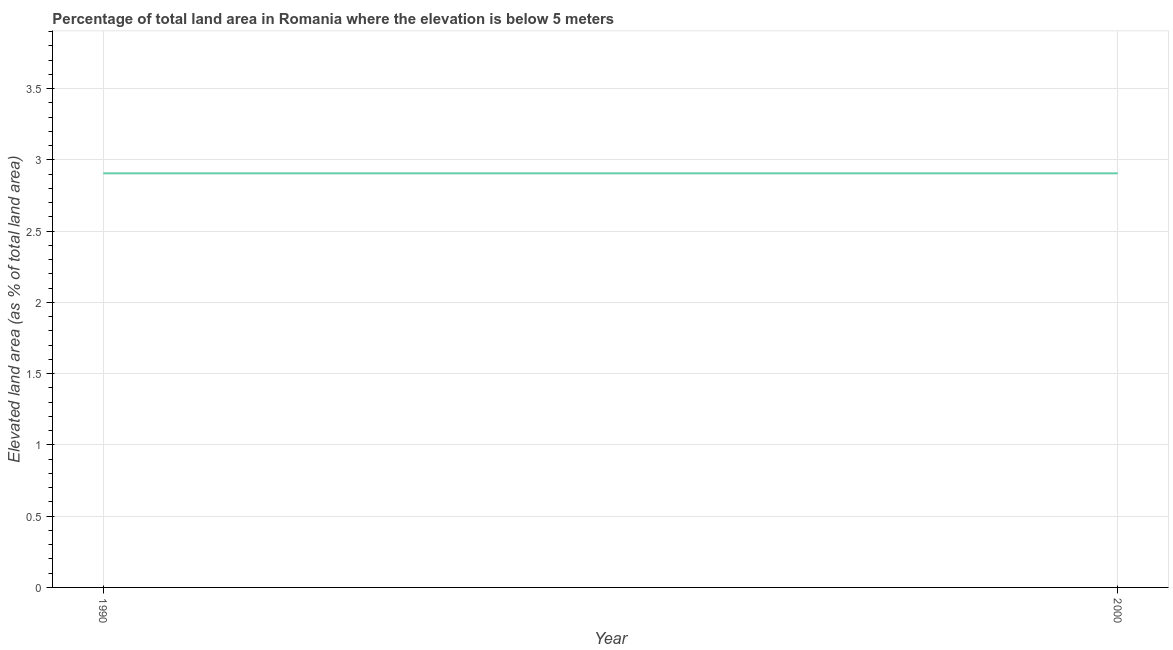What is the total elevated land area in 1990?
Give a very brief answer. 2.91. Across all years, what is the maximum total elevated land area?
Your answer should be very brief. 2.91. Across all years, what is the minimum total elevated land area?
Make the answer very short. 2.91. What is the sum of the total elevated land area?
Offer a very short reply. 5.81. What is the difference between the total elevated land area in 1990 and 2000?
Give a very brief answer. 0. What is the average total elevated land area per year?
Give a very brief answer. 2.91. What is the median total elevated land area?
Offer a very short reply. 2.91. Do a majority of the years between 1990 and 2000 (inclusive) have total elevated land area greater than 1.3 %?
Make the answer very short. Yes. Is the total elevated land area in 1990 less than that in 2000?
Give a very brief answer. No. In how many years, is the total elevated land area greater than the average total elevated land area taken over all years?
Give a very brief answer. 0. Does the total elevated land area monotonically increase over the years?
Make the answer very short. No. How many lines are there?
Offer a terse response. 1. What is the difference between two consecutive major ticks on the Y-axis?
Ensure brevity in your answer.  0.5. Are the values on the major ticks of Y-axis written in scientific E-notation?
Make the answer very short. No. What is the title of the graph?
Ensure brevity in your answer.  Percentage of total land area in Romania where the elevation is below 5 meters. What is the label or title of the X-axis?
Provide a succinct answer. Year. What is the label or title of the Y-axis?
Offer a terse response. Elevated land area (as % of total land area). What is the Elevated land area (as % of total land area) in 1990?
Ensure brevity in your answer.  2.91. What is the Elevated land area (as % of total land area) in 2000?
Provide a succinct answer. 2.91. 